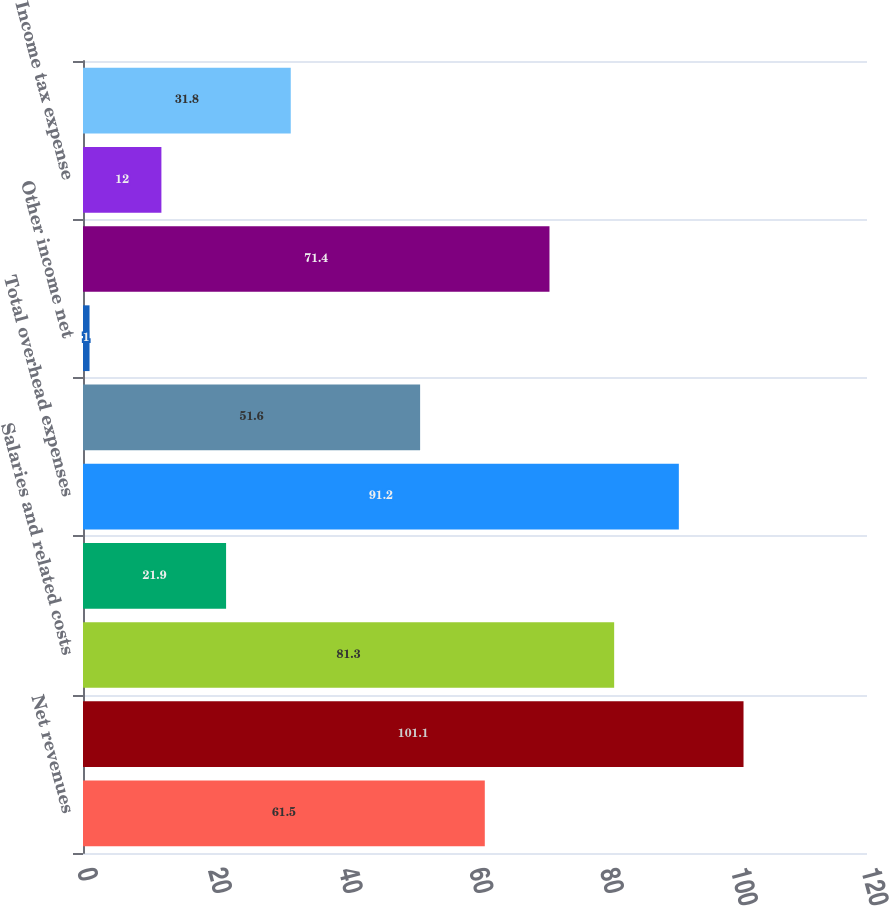Convert chart. <chart><loc_0><loc_0><loc_500><loc_500><bar_chart><fcel>Net revenues<fcel>Total net revenues<fcel>Salaries and related costs<fcel>Other<fcel>Total overhead expenses<fcel>Operating income<fcel>Other income net<fcel>Earnings before income taxes<fcel>Income tax expense<fcel>Net earnings<nl><fcel>61.5<fcel>101.1<fcel>81.3<fcel>21.9<fcel>91.2<fcel>51.6<fcel>1<fcel>71.4<fcel>12<fcel>31.8<nl></chart> 